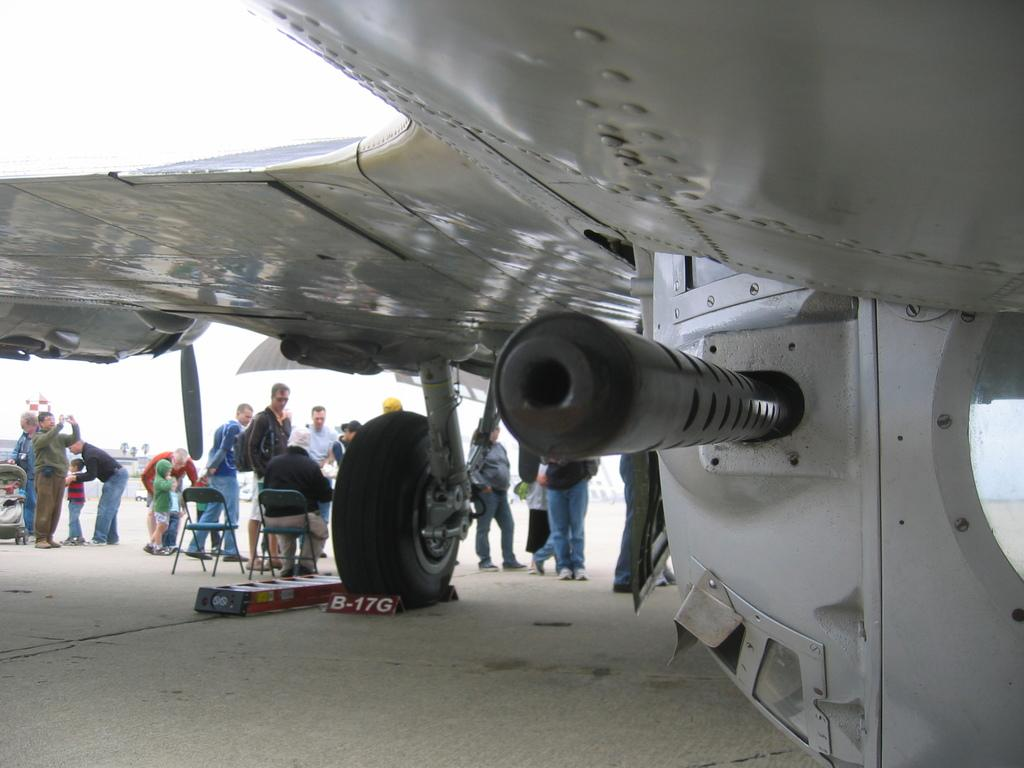Provide a one-sentence caption for the provided image. The block on the plane's wheel has the number B-17G. 